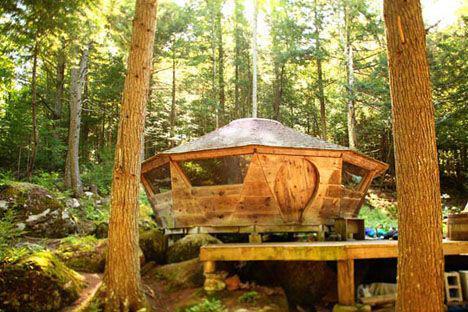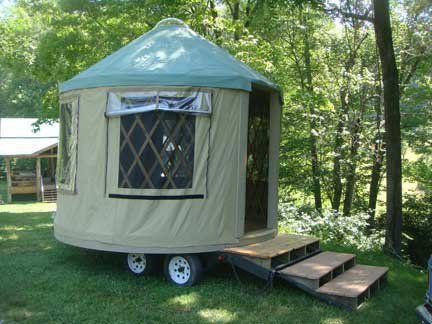The first image is the image on the left, the second image is the image on the right. Considering the images on both sides, is "Two round houses are dark teal green with light colored conical roofs." valid? Answer yes or no. No. 